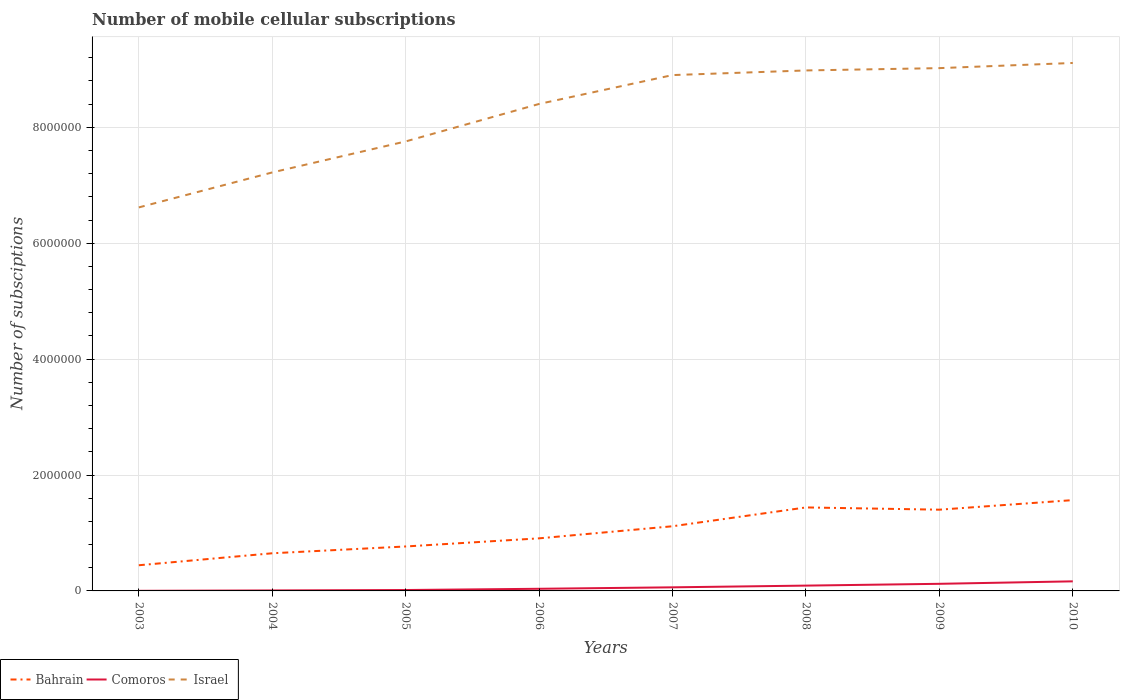Does the line corresponding to Comoros intersect with the line corresponding to Israel?
Ensure brevity in your answer.  No. Is the number of lines equal to the number of legend labels?
Your answer should be compact. Yes. In which year was the number of mobile cellular subscriptions in Israel maximum?
Offer a terse response. 2003. What is the total number of mobile cellular subscriptions in Comoros in the graph?
Your response must be concise. -8.57e+04. What is the difference between the highest and the second highest number of mobile cellular subscriptions in Comoros?
Provide a succinct answer. 1.63e+05. What is the difference between the highest and the lowest number of mobile cellular subscriptions in Comoros?
Offer a terse response. 3. Is the number of mobile cellular subscriptions in Israel strictly greater than the number of mobile cellular subscriptions in Bahrain over the years?
Provide a short and direct response. No. How many lines are there?
Ensure brevity in your answer.  3. Does the graph contain any zero values?
Offer a terse response. No. Where does the legend appear in the graph?
Give a very brief answer. Bottom left. How many legend labels are there?
Offer a terse response. 3. How are the legend labels stacked?
Offer a very short reply. Horizontal. What is the title of the graph?
Offer a terse response. Number of mobile cellular subscriptions. What is the label or title of the X-axis?
Provide a succinct answer. Years. What is the label or title of the Y-axis?
Provide a short and direct response. Number of subsciptions. What is the Number of subsciptions in Bahrain in 2003?
Your answer should be very brief. 4.43e+05. What is the Number of subsciptions in Israel in 2003?
Your answer should be compact. 6.62e+06. What is the Number of subsciptions in Bahrain in 2004?
Provide a short and direct response. 6.50e+05. What is the Number of subsciptions of Comoros in 2004?
Ensure brevity in your answer.  8378. What is the Number of subsciptions of Israel in 2004?
Your answer should be compact. 7.22e+06. What is the Number of subsciptions in Bahrain in 2005?
Keep it short and to the point. 7.67e+05. What is the Number of subsciptions in Comoros in 2005?
Keep it short and to the point. 1.55e+04. What is the Number of subsciptions of Israel in 2005?
Ensure brevity in your answer.  7.76e+06. What is the Number of subsciptions in Bahrain in 2006?
Your answer should be compact. 9.07e+05. What is the Number of subsciptions of Comoros in 2006?
Your response must be concise. 3.69e+04. What is the Number of subsciptions in Israel in 2006?
Make the answer very short. 8.40e+06. What is the Number of subsciptions in Bahrain in 2007?
Keep it short and to the point. 1.12e+06. What is the Number of subsciptions of Comoros in 2007?
Your answer should be very brief. 6.21e+04. What is the Number of subsciptions of Israel in 2007?
Offer a terse response. 8.90e+06. What is the Number of subsciptions in Bahrain in 2008?
Your answer should be very brief. 1.44e+06. What is the Number of subsciptions in Comoros in 2008?
Keep it short and to the point. 9.17e+04. What is the Number of subsciptions in Israel in 2008?
Provide a succinct answer. 8.98e+06. What is the Number of subsciptions in Bahrain in 2009?
Provide a short and direct response. 1.40e+06. What is the Number of subsciptions in Comoros in 2009?
Provide a succinct answer. 1.23e+05. What is the Number of subsciptions in Israel in 2009?
Your answer should be compact. 9.02e+06. What is the Number of subsciptions in Bahrain in 2010?
Give a very brief answer. 1.57e+06. What is the Number of subsciptions in Comoros in 2010?
Ensure brevity in your answer.  1.65e+05. What is the Number of subsciptions in Israel in 2010?
Your answer should be very brief. 9.11e+06. Across all years, what is the maximum Number of subsciptions of Bahrain?
Keep it short and to the point. 1.57e+06. Across all years, what is the maximum Number of subsciptions in Comoros?
Give a very brief answer. 1.65e+05. Across all years, what is the maximum Number of subsciptions of Israel?
Your answer should be very brief. 9.11e+06. Across all years, what is the minimum Number of subsciptions in Bahrain?
Offer a terse response. 4.43e+05. Across all years, what is the minimum Number of subsciptions of Comoros?
Provide a short and direct response. 2000. Across all years, what is the minimum Number of subsciptions in Israel?
Offer a terse response. 6.62e+06. What is the total Number of subsciptions in Bahrain in the graph?
Provide a succinct answer. 8.29e+06. What is the total Number of subsciptions in Comoros in the graph?
Your answer should be compact. 5.04e+05. What is the total Number of subsciptions of Israel in the graph?
Offer a very short reply. 6.60e+07. What is the difference between the Number of subsciptions of Bahrain in 2003 and that in 2004?
Provide a succinct answer. -2.07e+05. What is the difference between the Number of subsciptions of Comoros in 2003 and that in 2004?
Provide a short and direct response. -6378. What is the difference between the Number of subsciptions of Israel in 2003 and that in 2004?
Offer a terse response. -6.04e+05. What is the difference between the Number of subsciptions in Bahrain in 2003 and that in 2005?
Offer a very short reply. -3.24e+05. What is the difference between the Number of subsciptions in Comoros in 2003 and that in 2005?
Ensure brevity in your answer.  -1.35e+04. What is the difference between the Number of subsciptions of Israel in 2003 and that in 2005?
Make the answer very short. -1.14e+06. What is the difference between the Number of subsciptions of Bahrain in 2003 and that in 2006?
Your answer should be compact. -4.64e+05. What is the difference between the Number of subsciptions in Comoros in 2003 and that in 2006?
Provide a succinct answer. -3.49e+04. What is the difference between the Number of subsciptions in Israel in 2003 and that in 2006?
Ensure brevity in your answer.  -1.79e+06. What is the difference between the Number of subsciptions of Bahrain in 2003 and that in 2007?
Give a very brief answer. -6.73e+05. What is the difference between the Number of subsciptions in Comoros in 2003 and that in 2007?
Your answer should be compact. -6.01e+04. What is the difference between the Number of subsciptions in Israel in 2003 and that in 2007?
Your response must be concise. -2.28e+06. What is the difference between the Number of subsciptions in Bahrain in 2003 and that in 2008?
Provide a short and direct response. -9.98e+05. What is the difference between the Number of subsciptions of Comoros in 2003 and that in 2008?
Your answer should be compact. -8.97e+04. What is the difference between the Number of subsciptions in Israel in 2003 and that in 2008?
Your response must be concise. -2.36e+06. What is the difference between the Number of subsciptions of Bahrain in 2003 and that in 2009?
Ensure brevity in your answer.  -9.59e+05. What is the difference between the Number of subsciptions in Comoros in 2003 and that in 2009?
Your answer should be very brief. -1.21e+05. What is the difference between the Number of subsciptions in Israel in 2003 and that in 2009?
Your answer should be very brief. -2.40e+06. What is the difference between the Number of subsciptions of Bahrain in 2003 and that in 2010?
Make the answer very short. -1.12e+06. What is the difference between the Number of subsciptions in Comoros in 2003 and that in 2010?
Your answer should be very brief. -1.63e+05. What is the difference between the Number of subsciptions of Israel in 2003 and that in 2010?
Offer a very short reply. -2.49e+06. What is the difference between the Number of subsciptions of Bahrain in 2004 and that in 2005?
Offer a very short reply. -1.17e+05. What is the difference between the Number of subsciptions of Comoros in 2004 and that in 2005?
Offer a very short reply. -7145. What is the difference between the Number of subsciptions of Israel in 2004 and that in 2005?
Your answer should be very brief. -5.35e+05. What is the difference between the Number of subsciptions of Bahrain in 2004 and that in 2006?
Your response must be concise. -2.58e+05. What is the difference between the Number of subsciptions of Comoros in 2004 and that in 2006?
Give a very brief answer. -2.85e+04. What is the difference between the Number of subsciptions of Israel in 2004 and that in 2006?
Keep it short and to the point. -1.18e+06. What is the difference between the Number of subsciptions in Bahrain in 2004 and that in 2007?
Your answer should be very brief. -4.66e+05. What is the difference between the Number of subsciptions in Comoros in 2004 and that in 2007?
Offer a terse response. -5.37e+04. What is the difference between the Number of subsciptions in Israel in 2004 and that in 2007?
Offer a very short reply. -1.68e+06. What is the difference between the Number of subsciptions of Bahrain in 2004 and that in 2008?
Provide a short and direct response. -7.91e+05. What is the difference between the Number of subsciptions of Comoros in 2004 and that in 2008?
Make the answer very short. -8.34e+04. What is the difference between the Number of subsciptions of Israel in 2004 and that in 2008?
Provide a short and direct response. -1.76e+06. What is the difference between the Number of subsciptions of Bahrain in 2004 and that in 2009?
Your answer should be compact. -7.52e+05. What is the difference between the Number of subsciptions of Comoros in 2004 and that in 2009?
Your answer should be very brief. -1.14e+05. What is the difference between the Number of subsciptions in Israel in 2004 and that in 2009?
Your answer should be compact. -1.80e+06. What is the difference between the Number of subsciptions in Bahrain in 2004 and that in 2010?
Your response must be concise. -9.17e+05. What is the difference between the Number of subsciptions in Comoros in 2004 and that in 2010?
Offer a terse response. -1.57e+05. What is the difference between the Number of subsciptions in Israel in 2004 and that in 2010?
Provide a short and direct response. -1.89e+06. What is the difference between the Number of subsciptions in Bahrain in 2005 and that in 2006?
Your answer should be very brief. -1.40e+05. What is the difference between the Number of subsciptions of Comoros in 2005 and that in 2006?
Provide a short and direct response. -2.14e+04. What is the difference between the Number of subsciptions of Israel in 2005 and that in 2006?
Provide a succinct answer. -6.47e+05. What is the difference between the Number of subsciptions in Bahrain in 2005 and that in 2007?
Make the answer very short. -3.49e+05. What is the difference between the Number of subsciptions of Comoros in 2005 and that in 2007?
Your answer should be very brief. -4.66e+04. What is the difference between the Number of subsciptions in Israel in 2005 and that in 2007?
Your response must be concise. -1.14e+06. What is the difference between the Number of subsciptions in Bahrain in 2005 and that in 2008?
Offer a very short reply. -6.74e+05. What is the difference between the Number of subsciptions of Comoros in 2005 and that in 2008?
Provide a succinct answer. -7.62e+04. What is the difference between the Number of subsciptions of Israel in 2005 and that in 2008?
Your answer should be very brief. -1.22e+06. What is the difference between the Number of subsciptions in Bahrain in 2005 and that in 2009?
Your answer should be compact. -6.35e+05. What is the difference between the Number of subsciptions of Comoros in 2005 and that in 2009?
Provide a succinct answer. -1.07e+05. What is the difference between the Number of subsciptions of Israel in 2005 and that in 2009?
Your answer should be very brief. -1.26e+06. What is the difference between the Number of subsciptions in Bahrain in 2005 and that in 2010?
Your answer should be very brief. -8.00e+05. What is the difference between the Number of subsciptions in Comoros in 2005 and that in 2010?
Your answer should be compact. -1.50e+05. What is the difference between the Number of subsciptions in Israel in 2005 and that in 2010?
Your answer should be very brief. -1.35e+06. What is the difference between the Number of subsciptions in Bahrain in 2006 and that in 2007?
Your answer should be very brief. -2.09e+05. What is the difference between the Number of subsciptions of Comoros in 2006 and that in 2007?
Provide a short and direct response. -2.52e+04. What is the difference between the Number of subsciptions in Israel in 2006 and that in 2007?
Give a very brief answer. -4.98e+05. What is the difference between the Number of subsciptions in Bahrain in 2006 and that in 2008?
Give a very brief answer. -5.33e+05. What is the difference between the Number of subsciptions of Comoros in 2006 and that in 2008?
Provide a short and direct response. -5.49e+04. What is the difference between the Number of subsciptions in Israel in 2006 and that in 2008?
Give a very brief answer. -5.78e+05. What is the difference between the Number of subsciptions of Bahrain in 2006 and that in 2009?
Your response must be concise. -4.95e+05. What is the difference between the Number of subsciptions of Comoros in 2006 and that in 2009?
Ensure brevity in your answer.  -8.57e+04. What is the difference between the Number of subsciptions in Israel in 2006 and that in 2009?
Ensure brevity in your answer.  -6.18e+05. What is the difference between the Number of subsciptions in Bahrain in 2006 and that in 2010?
Your response must be concise. -6.60e+05. What is the difference between the Number of subsciptions of Comoros in 2006 and that in 2010?
Your answer should be very brief. -1.28e+05. What is the difference between the Number of subsciptions in Israel in 2006 and that in 2010?
Offer a very short reply. -7.07e+05. What is the difference between the Number of subsciptions in Bahrain in 2007 and that in 2008?
Provide a succinct answer. -3.25e+05. What is the difference between the Number of subsciptions of Comoros in 2007 and that in 2008?
Your answer should be very brief. -2.96e+04. What is the difference between the Number of subsciptions of Bahrain in 2007 and that in 2009?
Keep it short and to the point. -2.86e+05. What is the difference between the Number of subsciptions of Comoros in 2007 and that in 2009?
Keep it short and to the point. -6.05e+04. What is the difference between the Number of subsciptions in Israel in 2007 and that in 2009?
Your answer should be compact. -1.20e+05. What is the difference between the Number of subsciptions in Bahrain in 2007 and that in 2010?
Give a very brief answer. -4.51e+05. What is the difference between the Number of subsciptions in Comoros in 2007 and that in 2010?
Provide a short and direct response. -1.03e+05. What is the difference between the Number of subsciptions in Israel in 2007 and that in 2010?
Offer a very short reply. -2.09e+05. What is the difference between the Number of subsciptions of Bahrain in 2008 and that in 2009?
Offer a very short reply. 3.88e+04. What is the difference between the Number of subsciptions in Comoros in 2008 and that in 2009?
Offer a very short reply. -3.09e+04. What is the difference between the Number of subsciptions of Bahrain in 2008 and that in 2010?
Offer a very short reply. -1.26e+05. What is the difference between the Number of subsciptions of Comoros in 2008 and that in 2010?
Your response must be concise. -7.35e+04. What is the difference between the Number of subsciptions of Israel in 2008 and that in 2010?
Ensure brevity in your answer.  -1.29e+05. What is the difference between the Number of subsciptions of Bahrain in 2009 and that in 2010?
Offer a very short reply. -1.65e+05. What is the difference between the Number of subsciptions of Comoros in 2009 and that in 2010?
Keep it short and to the point. -4.27e+04. What is the difference between the Number of subsciptions in Israel in 2009 and that in 2010?
Keep it short and to the point. -8.90e+04. What is the difference between the Number of subsciptions of Bahrain in 2003 and the Number of subsciptions of Comoros in 2004?
Make the answer very short. 4.35e+05. What is the difference between the Number of subsciptions in Bahrain in 2003 and the Number of subsciptions in Israel in 2004?
Your response must be concise. -6.78e+06. What is the difference between the Number of subsciptions of Comoros in 2003 and the Number of subsciptions of Israel in 2004?
Ensure brevity in your answer.  -7.22e+06. What is the difference between the Number of subsciptions of Bahrain in 2003 and the Number of subsciptions of Comoros in 2005?
Your response must be concise. 4.28e+05. What is the difference between the Number of subsciptions of Bahrain in 2003 and the Number of subsciptions of Israel in 2005?
Your response must be concise. -7.31e+06. What is the difference between the Number of subsciptions of Comoros in 2003 and the Number of subsciptions of Israel in 2005?
Ensure brevity in your answer.  -7.76e+06. What is the difference between the Number of subsciptions of Bahrain in 2003 and the Number of subsciptions of Comoros in 2006?
Your answer should be compact. 4.06e+05. What is the difference between the Number of subsciptions in Bahrain in 2003 and the Number of subsciptions in Israel in 2006?
Your answer should be compact. -7.96e+06. What is the difference between the Number of subsciptions in Comoros in 2003 and the Number of subsciptions in Israel in 2006?
Your answer should be very brief. -8.40e+06. What is the difference between the Number of subsciptions of Bahrain in 2003 and the Number of subsciptions of Comoros in 2007?
Keep it short and to the point. 3.81e+05. What is the difference between the Number of subsciptions in Bahrain in 2003 and the Number of subsciptions in Israel in 2007?
Offer a very short reply. -8.46e+06. What is the difference between the Number of subsciptions in Comoros in 2003 and the Number of subsciptions in Israel in 2007?
Offer a very short reply. -8.90e+06. What is the difference between the Number of subsciptions in Bahrain in 2003 and the Number of subsciptions in Comoros in 2008?
Your answer should be very brief. 3.51e+05. What is the difference between the Number of subsciptions of Bahrain in 2003 and the Number of subsciptions of Israel in 2008?
Provide a short and direct response. -8.54e+06. What is the difference between the Number of subsciptions of Comoros in 2003 and the Number of subsciptions of Israel in 2008?
Make the answer very short. -8.98e+06. What is the difference between the Number of subsciptions of Bahrain in 2003 and the Number of subsciptions of Comoros in 2009?
Provide a short and direct response. 3.21e+05. What is the difference between the Number of subsciptions of Bahrain in 2003 and the Number of subsciptions of Israel in 2009?
Make the answer very short. -8.58e+06. What is the difference between the Number of subsciptions in Comoros in 2003 and the Number of subsciptions in Israel in 2009?
Your answer should be compact. -9.02e+06. What is the difference between the Number of subsciptions in Bahrain in 2003 and the Number of subsciptions in Comoros in 2010?
Give a very brief answer. 2.78e+05. What is the difference between the Number of subsciptions of Bahrain in 2003 and the Number of subsciptions of Israel in 2010?
Your answer should be very brief. -8.67e+06. What is the difference between the Number of subsciptions in Comoros in 2003 and the Number of subsciptions in Israel in 2010?
Offer a very short reply. -9.11e+06. What is the difference between the Number of subsciptions of Bahrain in 2004 and the Number of subsciptions of Comoros in 2005?
Give a very brief answer. 6.34e+05. What is the difference between the Number of subsciptions of Bahrain in 2004 and the Number of subsciptions of Israel in 2005?
Provide a short and direct response. -7.11e+06. What is the difference between the Number of subsciptions of Comoros in 2004 and the Number of subsciptions of Israel in 2005?
Ensure brevity in your answer.  -7.75e+06. What is the difference between the Number of subsciptions in Bahrain in 2004 and the Number of subsciptions in Comoros in 2006?
Give a very brief answer. 6.13e+05. What is the difference between the Number of subsciptions of Bahrain in 2004 and the Number of subsciptions of Israel in 2006?
Your answer should be very brief. -7.75e+06. What is the difference between the Number of subsciptions in Comoros in 2004 and the Number of subsciptions in Israel in 2006?
Your response must be concise. -8.40e+06. What is the difference between the Number of subsciptions in Bahrain in 2004 and the Number of subsciptions in Comoros in 2007?
Provide a short and direct response. 5.88e+05. What is the difference between the Number of subsciptions of Bahrain in 2004 and the Number of subsciptions of Israel in 2007?
Make the answer very short. -8.25e+06. What is the difference between the Number of subsciptions in Comoros in 2004 and the Number of subsciptions in Israel in 2007?
Provide a succinct answer. -8.89e+06. What is the difference between the Number of subsciptions in Bahrain in 2004 and the Number of subsciptions in Comoros in 2008?
Provide a succinct answer. 5.58e+05. What is the difference between the Number of subsciptions in Bahrain in 2004 and the Number of subsciptions in Israel in 2008?
Offer a terse response. -8.33e+06. What is the difference between the Number of subsciptions of Comoros in 2004 and the Number of subsciptions of Israel in 2008?
Provide a short and direct response. -8.97e+06. What is the difference between the Number of subsciptions of Bahrain in 2004 and the Number of subsciptions of Comoros in 2009?
Offer a very short reply. 5.27e+05. What is the difference between the Number of subsciptions in Bahrain in 2004 and the Number of subsciptions in Israel in 2009?
Your response must be concise. -8.37e+06. What is the difference between the Number of subsciptions in Comoros in 2004 and the Number of subsciptions in Israel in 2009?
Make the answer very short. -9.01e+06. What is the difference between the Number of subsciptions of Bahrain in 2004 and the Number of subsciptions of Comoros in 2010?
Your answer should be very brief. 4.84e+05. What is the difference between the Number of subsciptions in Bahrain in 2004 and the Number of subsciptions in Israel in 2010?
Provide a short and direct response. -8.46e+06. What is the difference between the Number of subsciptions in Comoros in 2004 and the Number of subsciptions in Israel in 2010?
Offer a terse response. -9.10e+06. What is the difference between the Number of subsciptions in Bahrain in 2005 and the Number of subsciptions in Comoros in 2006?
Your response must be concise. 7.30e+05. What is the difference between the Number of subsciptions of Bahrain in 2005 and the Number of subsciptions of Israel in 2006?
Your answer should be compact. -7.64e+06. What is the difference between the Number of subsciptions of Comoros in 2005 and the Number of subsciptions of Israel in 2006?
Offer a terse response. -8.39e+06. What is the difference between the Number of subsciptions of Bahrain in 2005 and the Number of subsciptions of Comoros in 2007?
Keep it short and to the point. 7.05e+05. What is the difference between the Number of subsciptions of Bahrain in 2005 and the Number of subsciptions of Israel in 2007?
Your answer should be compact. -8.13e+06. What is the difference between the Number of subsciptions in Comoros in 2005 and the Number of subsciptions in Israel in 2007?
Ensure brevity in your answer.  -8.89e+06. What is the difference between the Number of subsciptions of Bahrain in 2005 and the Number of subsciptions of Comoros in 2008?
Offer a very short reply. 6.75e+05. What is the difference between the Number of subsciptions of Bahrain in 2005 and the Number of subsciptions of Israel in 2008?
Keep it short and to the point. -8.21e+06. What is the difference between the Number of subsciptions of Comoros in 2005 and the Number of subsciptions of Israel in 2008?
Keep it short and to the point. -8.97e+06. What is the difference between the Number of subsciptions of Bahrain in 2005 and the Number of subsciptions of Comoros in 2009?
Ensure brevity in your answer.  6.45e+05. What is the difference between the Number of subsciptions of Bahrain in 2005 and the Number of subsciptions of Israel in 2009?
Make the answer very short. -8.25e+06. What is the difference between the Number of subsciptions of Comoros in 2005 and the Number of subsciptions of Israel in 2009?
Your answer should be compact. -9.01e+06. What is the difference between the Number of subsciptions in Bahrain in 2005 and the Number of subsciptions in Comoros in 2010?
Your response must be concise. 6.02e+05. What is the difference between the Number of subsciptions in Bahrain in 2005 and the Number of subsciptions in Israel in 2010?
Your response must be concise. -8.34e+06. What is the difference between the Number of subsciptions of Comoros in 2005 and the Number of subsciptions of Israel in 2010?
Keep it short and to the point. -9.10e+06. What is the difference between the Number of subsciptions of Bahrain in 2006 and the Number of subsciptions of Comoros in 2007?
Your answer should be very brief. 8.45e+05. What is the difference between the Number of subsciptions of Bahrain in 2006 and the Number of subsciptions of Israel in 2007?
Offer a very short reply. -7.99e+06. What is the difference between the Number of subsciptions in Comoros in 2006 and the Number of subsciptions in Israel in 2007?
Keep it short and to the point. -8.87e+06. What is the difference between the Number of subsciptions of Bahrain in 2006 and the Number of subsciptions of Comoros in 2008?
Offer a terse response. 8.16e+05. What is the difference between the Number of subsciptions in Bahrain in 2006 and the Number of subsciptions in Israel in 2008?
Offer a very short reply. -8.07e+06. What is the difference between the Number of subsciptions in Comoros in 2006 and the Number of subsciptions in Israel in 2008?
Offer a terse response. -8.95e+06. What is the difference between the Number of subsciptions of Bahrain in 2006 and the Number of subsciptions of Comoros in 2009?
Your answer should be very brief. 7.85e+05. What is the difference between the Number of subsciptions of Bahrain in 2006 and the Number of subsciptions of Israel in 2009?
Make the answer very short. -8.11e+06. What is the difference between the Number of subsciptions of Comoros in 2006 and the Number of subsciptions of Israel in 2009?
Keep it short and to the point. -8.99e+06. What is the difference between the Number of subsciptions in Bahrain in 2006 and the Number of subsciptions in Comoros in 2010?
Keep it short and to the point. 7.42e+05. What is the difference between the Number of subsciptions of Bahrain in 2006 and the Number of subsciptions of Israel in 2010?
Give a very brief answer. -8.20e+06. What is the difference between the Number of subsciptions of Comoros in 2006 and the Number of subsciptions of Israel in 2010?
Offer a terse response. -9.07e+06. What is the difference between the Number of subsciptions of Bahrain in 2007 and the Number of subsciptions of Comoros in 2008?
Ensure brevity in your answer.  1.02e+06. What is the difference between the Number of subsciptions of Bahrain in 2007 and the Number of subsciptions of Israel in 2008?
Your answer should be compact. -7.87e+06. What is the difference between the Number of subsciptions of Comoros in 2007 and the Number of subsciptions of Israel in 2008?
Your answer should be compact. -8.92e+06. What is the difference between the Number of subsciptions in Bahrain in 2007 and the Number of subsciptions in Comoros in 2009?
Provide a succinct answer. 9.93e+05. What is the difference between the Number of subsciptions in Bahrain in 2007 and the Number of subsciptions in Israel in 2009?
Your response must be concise. -7.91e+06. What is the difference between the Number of subsciptions of Comoros in 2007 and the Number of subsciptions of Israel in 2009?
Provide a short and direct response. -8.96e+06. What is the difference between the Number of subsciptions of Bahrain in 2007 and the Number of subsciptions of Comoros in 2010?
Provide a succinct answer. 9.51e+05. What is the difference between the Number of subsciptions of Bahrain in 2007 and the Number of subsciptions of Israel in 2010?
Keep it short and to the point. -8.00e+06. What is the difference between the Number of subsciptions in Comoros in 2007 and the Number of subsciptions in Israel in 2010?
Make the answer very short. -9.05e+06. What is the difference between the Number of subsciptions in Bahrain in 2008 and the Number of subsciptions in Comoros in 2009?
Provide a short and direct response. 1.32e+06. What is the difference between the Number of subsciptions of Bahrain in 2008 and the Number of subsciptions of Israel in 2009?
Provide a short and direct response. -7.58e+06. What is the difference between the Number of subsciptions of Comoros in 2008 and the Number of subsciptions of Israel in 2009?
Your answer should be very brief. -8.93e+06. What is the difference between the Number of subsciptions of Bahrain in 2008 and the Number of subsciptions of Comoros in 2010?
Your answer should be very brief. 1.28e+06. What is the difference between the Number of subsciptions of Bahrain in 2008 and the Number of subsciptions of Israel in 2010?
Ensure brevity in your answer.  -7.67e+06. What is the difference between the Number of subsciptions in Comoros in 2008 and the Number of subsciptions in Israel in 2010?
Your response must be concise. -9.02e+06. What is the difference between the Number of subsciptions of Bahrain in 2009 and the Number of subsciptions of Comoros in 2010?
Your response must be concise. 1.24e+06. What is the difference between the Number of subsciptions of Bahrain in 2009 and the Number of subsciptions of Israel in 2010?
Offer a terse response. -7.71e+06. What is the difference between the Number of subsciptions in Comoros in 2009 and the Number of subsciptions in Israel in 2010?
Keep it short and to the point. -8.99e+06. What is the average Number of subsciptions in Bahrain per year?
Offer a terse response. 1.04e+06. What is the average Number of subsciptions of Comoros per year?
Your response must be concise. 6.31e+04. What is the average Number of subsciptions in Israel per year?
Keep it short and to the point. 8.25e+06. In the year 2003, what is the difference between the Number of subsciptions of Bahrain and Number of subsciptions of Comoros?
Keep it short and to the point. 4.41e+05. In the year 2003, what is the difference between the Number of subsciptions in Bahrain and Number of subsciptions in Israel?
Your answer should be very brief. -6.18e+06. In the year 2003, what is the difference between the Number of subsciptions in Comoros and Number of subsciptions in Israel?
Offer a terse response. -6.62e+06. In the year 2004, what is the difference between the Number of subsciptions of Bahrain and Number of subsciptions of Comoros?
Provide a succinct answer. 6.41e+05. In the year 2004, what is the difference between the Number of subsciptions in Bahrain and Number of subsciptions in Israel?
Provide a succinct answer. -6.57e+06. In the year 2004, what is the difference between the Number of subsciptions of Comoros and Number of subsciptions of Israel?
Ensure brevity in your answer.  -7.21e+06. In the year 2005, what is the difference between the Number of subsciptions of Bahrain and Number of subsciptions of Comoros?
Offer a terse response. 7.52e+05. In the year 2005, what is the difference between the Number of subsciptions of Bahrain and Number of subsciptions of Israel?
Your response must be concise. -6.99e+06. In the year 2005, what is the difference between the Number of subsciptions in Comoros and Number of subsciptions in Israel?
Your response must be concise. -7.74e+06. In the year 2006, what is the difference between the Number of subsciptions in Bahrain and Number of subsciptions in Comoros?
Offer a terse response. 8.71e+05. In the year 2006, what is the difference between the Number of subsciptions of Bahrain and Number of subsciptions of Israel?
Ensure brevity in your answer.  -7.50e+06. In the year 2006, what is the difference between the Number of subsciptions of Comoros and Number of subsciptions of Israel?
Your response must be concise. -8.37e+06. In the year 2007, what is the difference between the Number of subsciptions in Bahrain and Number of subsciptions in Comoros?
Ensure brevity in your answer.  1.05e+06. In the year 2007, what is the difference between the Number of subsciptions of Bahrain and Number of subsciptions of Israel?
Your response must be concise. -7.79e+06. In the year 2007, what is the difference between the Number of subsciptions of Comoros and Number of subsciptions of Israel?
Provide a succinct answer. -8.84e+06. In the year 2008, what is the difference between the Number of subsciptions of Bahrain and Number of subsciptions of Comoros?
Your answer should be compact. 1.35e+06. In the year 2008, what is the difference between the Number of subsciptions in Bahrain and Number of subsciptions in Israel?
Your answer should be very brief. -7.54e+06. In the year 2008, what is the difference between the Number of subsciptions of Comoros and Number of subsciptions of Israel?
Give a very brief answer. -8.89e+06. In the year 2009, what is the difference between the Number of subsciptions of Bahrain and Number of subsciptions of Comoros?
Provide a succinct answer. 1.28e+06. In the year 2009, what is the difference between the Number of subsciptions of Bahrain and Number of subsciptions of Israel?
Offer a very short reply. -7.62e+06. In the year 2009, what is the difference between the Number of subsciptions in Comoros and Number of subsciptions in Israel?
Make the answer very short. -8.90e+06. In the year 2010, what is the difference between the Number of subsciptions in Bahrain and Number of subsciptions in Comoros?
Ensure brevity in your answer.  1.40e+06. In the year 2010, what is the difference between the Number of subsciptions in Bahrain and Number of subsciptions in Israel?
Your response must be concise. -7.54e+06. In the year 2010, what is the difference between the Number of subsciptions in Comoros and Number of subsciptions in Israel?
Ensure brevity in your answer.  -8.95e+06. What is the ratio of the Number of subsciptions in Bahrain in 2003 to that in 2004?
Your answer should be very brief. 0.68. What is the ratio of the Number of subsciptions in Comoros in 2003 to that in 2004?
Keep it short and to the point. 0.24. What is the ratio of the Number of subsciptions of Israel in 2003 to that in 2004?
Provide a short and direct response. 0.92. What is the ratio of the Number of subsciptions in Bahrain in 2003 to that in 2005?
Offer a terse response. 0.58. What is the ratio of the Number of subsciptions of Comoros in 2003 to that in 2005?
Your answer should be very brief. 0.13. What is the ratio of the Number of subsciptions in Israel in 2003 to that in 2005?
Provide a short and direct response. 0.85. What is the ratio of the Number of subsciptions in Bahrain in 2003 to that in 2006?
Ensure brevity in your answer.  0.49. What is the ratio of the Number of subsciptions of Comoros in 2003 to that in 2006?
Offer a terse response. 0.05. What is the ratio of the Number of subsciptions of Israel in 2003 to that in 2006?
Provide a succinct answer. 0.79. What is the ratio of the Number of subsciptions in Bahrain in 2003 to that in 2007?
Your answer should be very brief. 0.4. What is the ratio of the Number of subsciptions in Comoros in 2003 to that in 2007?
Provide a short and direct response. 0.03. What is the ratio of the Number of subsciptions of Israel in 2003 to that in 2007?
Offer a terse response. 0.74. What is the ratio of the Number of subsciptions of Bahrain in 2003 to that in 2008?
Keep it short and to the point. 0.31. What is the ratio of the Number of subsciptions in Comoros in 2003 to that in 2008?
Offer a terse response. 0.02. What is the ratio of the Number of subsciptions of Israel in 2003 to that in 2008?
Make the answer very short. 0.74. What is the ratio of the Number of subsciptions of Bahrain in 2003 to that in 2009?
Offer a very short reply. 0.32. What is the ratio of the Number of subsciptions in Comoros in 2003 to that in 2009?
Your answer should be compact. 0.02. What is the ratio of the Number of subsciptions in Israel in 2003 to that in 2009?
Offer a terse response. 0.73. What is the ratio of the Number of subsciptions in Bahrain in 2003 to that in 2010?
Your response must be concise. 0.28. What is the ratio of the Number of subsciptions in Comoros in 2003 to that in 2010?
Make the answer very short. 0.01. What is the ratio of the Number of subsciptions of Israel in 2003 to that in 2010?
Provide a succinct answer. 0.73. What is the ratio of the Number of subsciptions of Bahrain in 2004 to that in 2005?
Your response must be concise. 0.85. What is the ratio of the Number of subsciptions in Comoros in 2004 to that in 2005?
Make the answer very short. 0.54. What is the ratio of the Number of subsciptions of Israel in 2004 to that in 2005?
Your answer should be compact. 0.93. What is the ratio of the Number of subsciptions of Bahrain in 2004 to that in 2006?
Your response must be concise. 0.72. What is the ratio of the Number of subsciptions of Comoros in 2004 to that in 2006?
Ensure brevity in your answer.  0.23. What is the ratio of the Number of subsciptions of Israel in 2004 to that in 2006?
Give a very brief answer. 0.86. What is the ratio of the Number of subsciptions of Bahrain in 2004 to that in 2007?
Your answer should be compact. 0.58. What is the ratio of the Number of subsciptions in Comoros in 2004 to that in 2007?
Offer a very short reply. 0.13. What is the ratio of the Number of subsciptions of Israel in 2004 to that in 2007?
Offer a terse response. 0.81. What is the ratio of the Number of subsciptions of Bahrain in 2004 to that in 2008?
Ensure brevity in your answer.  0.45. What is the ratio of the Number of subsciptions in Comoros in 2004 to that in 2008?
Offer a very short reply. 0.09. What is the ratio of the Number of subsciptions of Israel in 2004 to that in 2008?
Your response must be concise. 0.8. What is the ratio of the Number of subsciptions of Bahrain in 2004 to that in 2009?
Your answer should be very brief. 0.46. What is the ratio of the Number of subsciptions in Comoros in 2004 to that in 2009?
Your answer should be very brief. 0.07. What is the ratio of the Number of subsciptions in Israel in 2004 to that in 2009?
Make the answer very short. 0.8. What is the ratio of the Number of subsciptions of Bahrain in 2004 to that in 2010?
Your answer should be very brief. 0.41. What is the ratio of the Number of subsciptions of Comoros in 2004 to that in 2010?
Make the answer very short. 0.05. What is the ratio of the Number of subsciptions in Israel in 2004 to that in 2010?
Offer a terse response. 0.79. What is the ratio of the Number of subsciptions in Bahrain in 2005 to that in 2006?
Ensure brevity in your answer.  0.85. What is the ratio of the Number of subsciptions of Comoros in 2005 to that in 2006?
Give a very brief answer. 0.42. What is the ratio of the Number of subsciptions in Israel in 2005 to that in 2006?
Offer a terse response. 0.92. What is the ratio of the Number of subsciptions of Bahrain in 2005 to that in 2007?
Offer a very short reply. 0.69. What is the ratio of the Number of subsciptions in Comoros in 2005 to that in 2007?
Your response must be concise. 0.25. What is the ratio of the Number of subsciptions in Israel in 2005 to that in 2007?
Give a very brief answer. 0.87. What is the ratio of the Number of subsciptions in Bahrain in 2005 to that in 2008?
Provide a short and direct response. 0.53. What is the ratio of the Number of subsciptions of Comoros in 2005 to that in 2008?
Your answer should be very brief. 0.17. What is the ratio of the Number of subsciptions in Israel in 2005 to that in 2008?
Your response must be concise. 0.86. What is the ratio of the Number of subsciptions of Bahrain in 2005 to that in 2009?
Make the answer very short. 0.55. What is the ratio of the Number of subsciptions in Comoros in 2005 to that in 2009?
Your answer should be very brief. 0.13. What is the ratio of the Number of subsciptions in Israel in 2005 to that in 2009?
Offer a very short reply. 0.86. What is the ratio of the Number of subsciptions in Bahrain in 2005 to that in 2010?
Your answer should be compact. 0.49. What is the ratio of the Number of subsciptions of Comoros in 2005 to that in 2010?
Your response must be concise. 0.09. What is the ratio of the Number of subsciptions of Israel in 2005 to that in 2010?
Your answer should be compact. 0.85. What is the ratio of the Number of subsciptions of Bahrain in 2006 to that in 2007?
Your answer should be compact. 0.81. What is the ratio of the Number of subsciptions of Comoros in 2006 to that in 2007?
Your answer should be very brief. 0.59. What is the ratio of the Number of subsciptions in Israel in 2006 to that in 2007?
Provide a succinct answer. 0.94. What is the ratio of the Number of subsciptions of Bahrain in 2006 to that in 2008?
Ensure brevity in your answer.  0.63. What is the ratio of the Number of subsciptions in Comoros in 2006 to that in 2008?
Give a very brief answer. 0.4. What is the ratio of the Number of subsciptions in Israel in 2006 to that in 2008?
Keep it short and to the point. 0.94. What is the ratio of the Number of subsciptions in Bahrain in 2006 to that in 2009?
Offer a terse response. 0.65. What is the ratio of the Number of subsciptions in Comoros in 2006 to that in 2009?
Give a very brief answer. 0.3. What is the ratio of the Number of subsciptions in Israel in 2006 to that in 2009?
Give a very brief answer. 0.93. What is the ratio of the Number of subsciptions of Bahrain in 2006 to that in 2010?
Make the answer very short. 0.58. What is the ratio of the Number of subsciptions of Comoros in 2006 to that in 2010?
Your answer should be very brief. 0.22. What is the ratio of the Number of subsciptions of Israel in 2006 to that in 2010?
Keep it short and to the point. 0.92. What is the ratio of the Number of subsciptions in Bahrain in 2007 to that in 2008?
Your response must be concise. 0.77. What is the ratio of the Number of subsciptions of Comoros in 2007 to that in 2008?
Ensure brevity in your answer.  0.68. What is the ratio of the Number of subsciptions in Bahrain in 2007 to that in 2009?
Give a very brief answer. 0.8. What is the ratio of the Number of subsciptions of Comoros in 2007 to that in 2009?
Keep it short and to the point. 0.51. What is the ratio of the Number of subsciptions of Israel in 2007 to that in 2009?
Make the answer very short. 0.99. What is the ratio of the Number of subsciptions of Bahrain in 2007 to that in 2010?
Offer a terse response. 0.71. What is the ratio of the Number of subsciptions of Comoros in 2007 to that in 2010?
Keep it short and to the point. 0.38. What is the ratio of the Number of subsciptions in Israel in 2007 to that in 2010?
Your answer should be very brief. 0.98. What is the ratio of the Number of subsciptions in Bahrain in 2008 to that in 2009?
Provide a short and direct response. 1.03. What is the ratio of the Number of subsciptions of Comoros in 2008 to that in 2009?
Offer a terse response. 0.75. What is the ratio of the Number of subsciptions of Israel in 2008 to that in 2009?
Make the answer very short. 1. What is the ratio of the Number of subsciptions of Bahrain in 2008 to that in 2010?
Provide a succinct answer. 0.92. What is the ratio of the Number of subsciptions in Comoros in 2008 to that in 2010?
Give a very brief answer. 0.56. What is the ratio of the Number of subsciptions of Israel in 2008 to that in 2010?
Your response must be concise. 0.99. What is the ratio of the Number of subsciptions in Bahrain in 2009 to that in 2010?
Your answer should be very brief. 0.89. What is the ratio of the Number of subsciptions in Comoros in 2009 to that in 2010?
Give a very brief answer. 0.74. What is the ratio of the Number of subsciptions of Israel in 2009 to that in 2010?
Your response must be concise. 0.99. What is the difference between the highest and the second highest Number of subsciptions of Bahrain?
Provide a succinct answer. 1.26e+05. What is the difference between the highest and the second highest Number of subsciptions of Comoros?
Ensure brevity in your answer.  4.27e+04. What is the difference between the highest and the second highest Number of subsciptions of Israel?
Your answer should be compact. 8.90e+04. What is the difference between the highest and the lowest Number of subsciptions in Bahrain?
Provide a short and direct response. 1.12e+06. What is the difference between the highest and the lowest Number of subsciptions in Comoros?
Offer a terse response. 1.63e+05. What is the difference between the highest and the lowest Number of subsciptions of Israel?
Your answer should be very brief. 2.49e+06. 